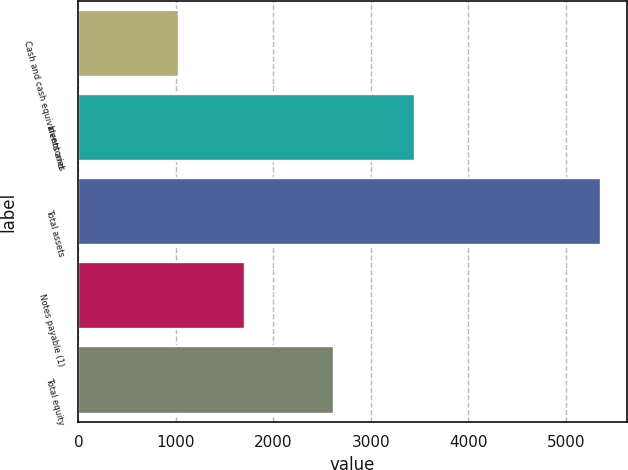Convert chart to OTSL. <chart><loc_0><loc_0><loc_500><loc_500><bar_chart><fcel>Cash and cash equivalents and<fcel>Inventories<fcel>Total assets<fcel>Notes payable (1)<fcel>Total equity<nl><fcel>1030.2<fcel>3449.7<fcel>5358.4<fcel>1704.6<fcel>2623.5<nl></chart> 